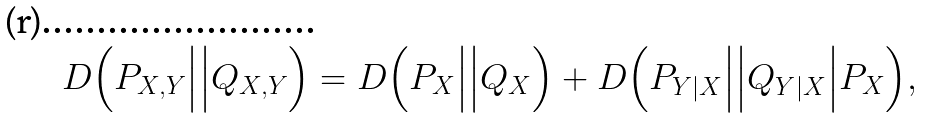<formula> <loc_0><loc_0><loc_500><loc_500>D \Big ( P _ { X , Y } \Big | \Big | Q _ { X , Y } \Big ) = D \Big ( P _ { X } \Big | \Big | Q _ { X } \Big ) + D \Big ( P _ { Y | X } \Big | \Big | Q _ { Y | X } \Big | P _ { X } \Big ) ,</formula> 